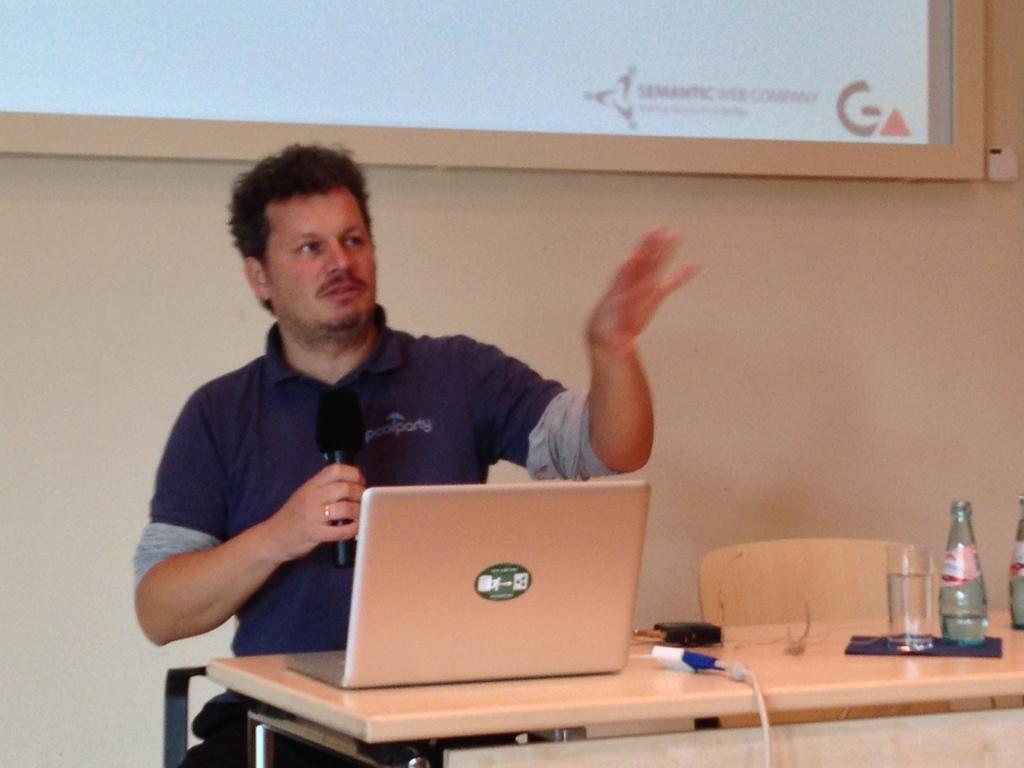Describe this image in one or two sentences. In this image in the front there is a table and on the table there is a laptop, there are bottles and there is a glass and there is a wire. In the center there is a person sitting on a chair and holding a mic in his hand and there is an empty chair. In the background there is a wall, on the wall there is a screen which is visible. 